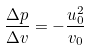Convert formula to latex. <formula><loc_0><loc_0><loc_500><loc_500>\frac { \Delta p } { \Delta v } = - \frac { u _ { 0 } ^ { 2 } } { v _ { 0 } }</formula> 